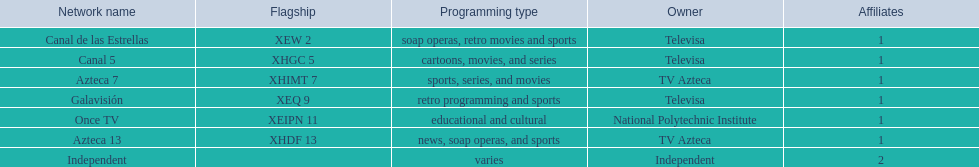Can you parse all the data within this table? {'header': ['Network name', 'Flagship', 'Programming type', 'Owner', 'Affiliates'], 'rows': [['Canal de las Estrellas', 'XEW 2', 'soap operas, retro movies and sports', 'Televisa', '1'], ['Canal 5', 'XHGC 5', 'cartoons, movies, and series', 'Televisa', '1'], ['Azteca 7', 'XHIMT 7', 'sports, series, and movies', 'TV Azteca', '1'], ['Galavisión', 'XEQ 9', 'retro programming and sports', 'Televisa', '1'], ['Once TV', 'XEIPN 11', 'educational and cultural', 'National Polytechnic Institute', '1'], ['Azteca 13', 'XHDF 13', 'news, soap operas, and sports', 'TV Azteca', '1'], ['Independent', '', 'varies', 'Independent', '2']]} On what network can you find cartoons? Canal 5. On what network do soap operas play? Canal de las Estrellas. On what network can you watch sports? Azteca 7. 